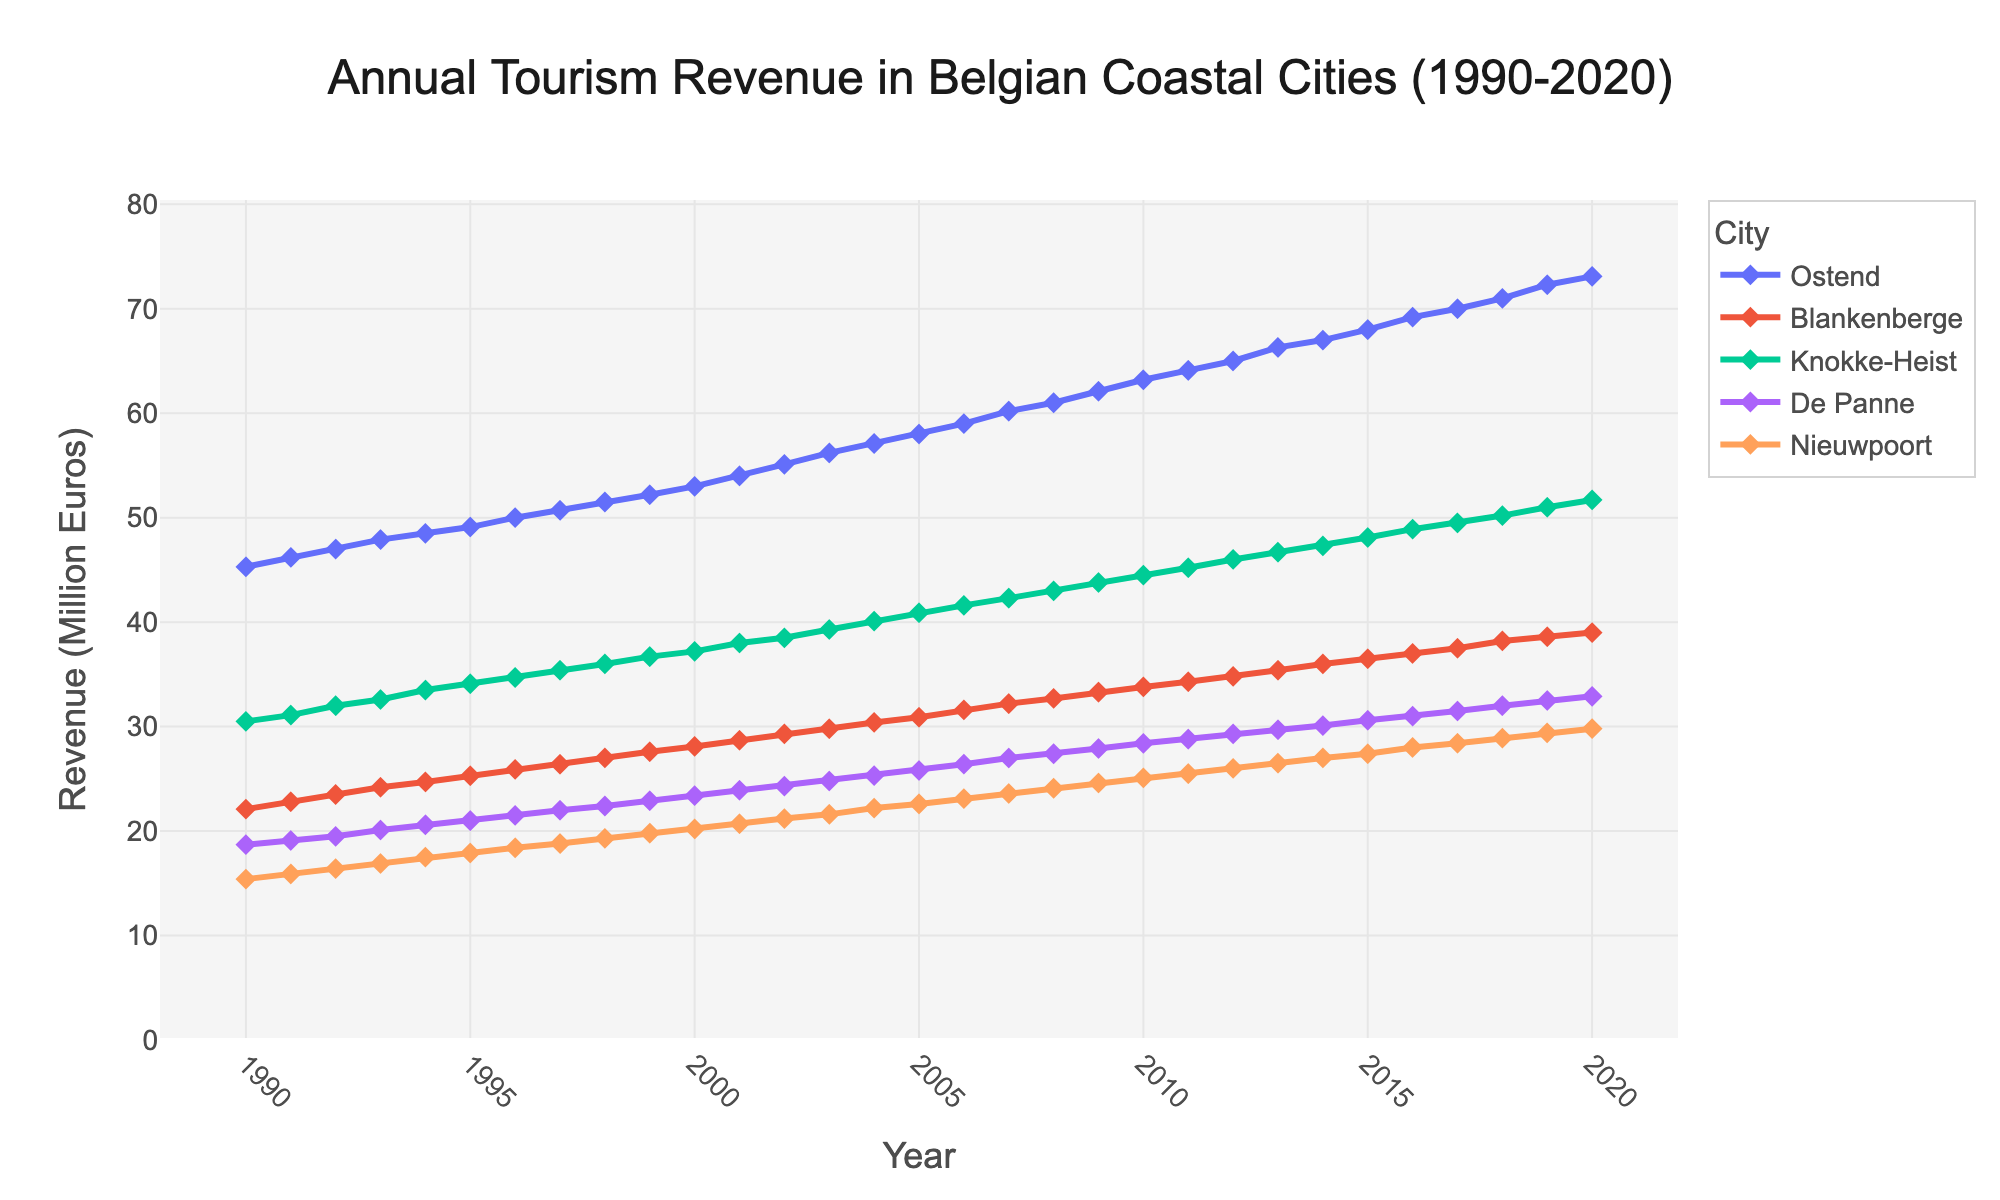What is the title of the figure? The title of the figure is located at the top-center of the plot. It gives a clear indication of what the plot represents.
Answer: Annual Tourism Revenue in Belgian Coastal Cities (1990-2020) Which city had the highest tourism revenue in 2020? To find the city with the highest tourism revenue in 2020, locate the year 2020 on the x-axis and identify the city that corresponds to the highest value on the y-axis.
Answer: Ostend Between which years did Nieuwpoort's tourism revenue first exceed 20 million euros? To find when Nieuwpoort's tourism revenue first exceeded 20 million euros, locate the y-axis where the revenue is 20 million euros and identify the corresponding year from the x-axis.
Answer: 2000 and 2001 By how much did tourism revenue in De Panne increase from 1990 to 2020? To calculate the increase in tourism revenue for De Panne, subtract the revenue in 1990 from the revenue in 2020.
Answer: 32.9 - 18.7 = 14.2 million euros Which city showed the least change in tourism revenue between 1990 and 2020? To determine the city with the least change, calculate the difference in revenue from 1990 to 2020 for each city and identify the smallest difference.
Answer: Blankenberge How many years did it take for Knokke-Heist's tourism revenue to reach 40 million euros starting from 1990? Identify the year when Knokke-Heist's revenue reaches 40 million euros and subtract 1990 from that year.
Answer: 2004 - 1990 = 14 years Did any city's tourism revenue decline in any year between 1990 and 2020? Examine the trend lines for each city and check for any downward segments indicating a decline in revenue.
Answer: No What was the average tourism revenue in Ostend over the 30-year period? Sum up the yearly revenues for Ostend from 1990 to 2020, then divide by the number of years (31).
Answer: (Sum of yearly revenues)/31 ≈ 58.57 million euros Which city's tourism revenue was closest to 30 million euros in the year 2015? Locate the year 2015 on the x-axis and check the cities' revenues. Identify which city’s revenue is closest to 30 million euros.
Answer: De Panne By how much did Blankenberge's tourism revenue grow from 2000 to 2010? Subtract Blankenberge's revenue in 2000 from its revenue in 2010 to find the growth amount.
Answer: 33.8 - 28.1 = 5.7 million euros 